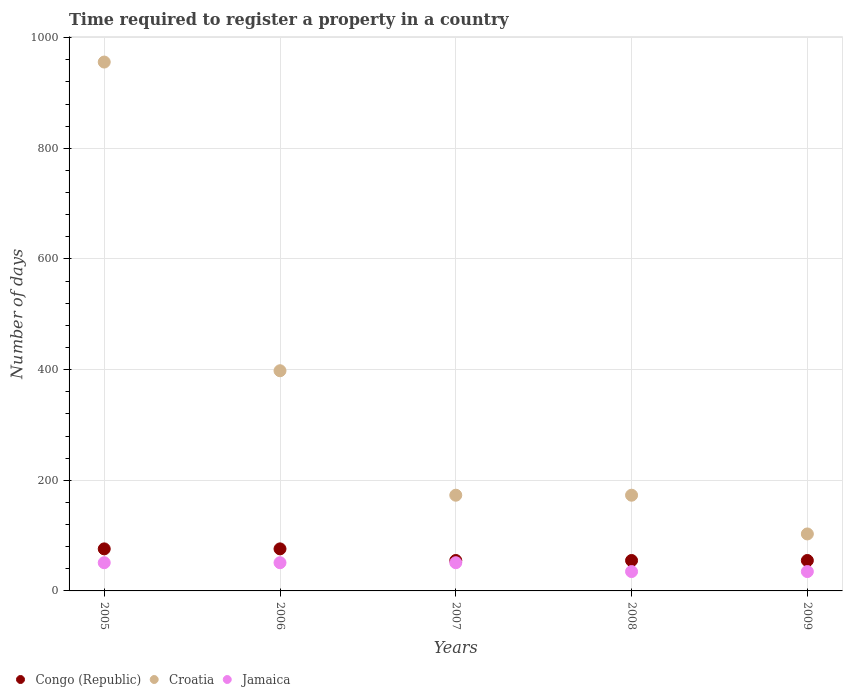Is the number of dotlines equal to the number of legend labels?
Your answer should be very brief. Yes. What is the number of days required to register a property in Congo (Republic) in 2005?
Offer a terse response. 76. Across all years, what is the maximum number of days required to register a property in Croatia?
Your answer should be very brief. 956. Across all years, what is the minimum number of days required to register a property in Congo (Republic)?
Keep it short and to the point. 55. What is the total number of days required to register a property in Jamaica in the graph?
Your response must be concise. 223. What is the difference between the number of days required to register a property in Croatia in 2005 and that in 2007?
Offer a very short reply. 783. What is the difference between the number of days required to register a property in Congo (Republic) in 2005 and the number of days required to register a property in Jamaica in 2007?
Keep it short and to the point. 25. What is the average number of days required to register a property in Croatia per year?
Give a very brief answer. 360.6. In how many years, is the number of days required to register a property in Jamaica greater than 280 days?
Your answer should be compact. 0. What is the ratio of the number of days required to register a property in Jamaica in 2007 to that in 2009?
Your answer should be compact. 1.46. Is the number of days required to register a property in Croatia in 2006 less than that in 2008?
Offer a terse response. No. What is the difference between the highest and the lowest number of days required to register a property in Jamaica?
Ensure brevity in your answer.  16. In how many years, is the number of days required to register a property in Jamaica greater than the average number of days required to register a property in Jamaica taken over all years?
Your answer should be very brief. 3. Is the sum of the number of days required to register a property in Croatia in 2005 and 2009 greater than the maximum number of days required to register a property in Jamaica across all years?
Your answer should be very brief. Yes. Does the number of days required to register a property in Congo (Republic) monotonically increase over the years?
Provide a succinct answer. No. Is the number of days required to register a property in Congo (Republic) strictly less than the number of days required to register a property in Croatia over the years?
Offer a very short reply. Yes. How many dotlines are there?
Keep it short and to the point. 3. Are the values on the major ticks of Y-axis written in scientific E-notation?
Provide a succinct answer. No. Does the graph contain any zero values?
Offer a terse response. No. What is the title of the graph?
Your response must be concise. Time required to register a property in a country. Does "Namibia" appear as one of the legend labels in the graph?
Keep it short and to the point. No. What is the label or title of the X-axis?
Give a very brief answer. Years. What is the label or title of the Y-axis?
Offer a terse response. Number of days. What is the Number of days of Croatia in 2005?
Ensure brevity in your answer.  956. What is the Number of days in Congo (Republic) in 2006?
Keep it short and to the point. 76. What is the Number of days in Croatia in 2006?
Your answer should be compact. 398. What is the Number of days of Congo (Republic) in 2007?
Keep it short and to the point. 55. What is the Number of days of Croatia in 2007?
Your response must be concise. 173. What is the Number of days in Congo (Republic) in 2008?
Make the answer very short. 55. What is the Number of days of Croatia in 2008?
Your answer should be very brief. 173. What is the Number of days in Congo (Republic) in 2009?
Your answer should be compact. 55. What is the Number of days in Croatia in 2009?
Offer a terse response. 103. Across all years, what is the maximum Number of days of Congo (Republic)?
Your answer should be very brief. 76. Across all years, what is the maximum Number of days in Croatia?
Your response must be concise. 956. Across all years, what is the minimum Number of days in Croatia?
Provide a short and direct response. 103. Across all years, what is the minimum Number of days in Jamaica?
Provide a short and direct response. 35. What is the total Number of days in Congo (Republic) in the graph?
Ensure brevity in your answer.  317. What is the total Number of days in Croatia in the graph?
Offer a very short reply. 1803. What is the total Number of days of Jamaica in the graph?
Keep it short and to the point. 223. What is the difference between the Number of days in Croatia in 2005 and that in 2006?
Offer a terse response. 558. What is the difference between the Number of days in Jamaica in 2005 and that in 2006?
Provide a short and direct response. 0. What is the difference between the Number of days in Congo (Republic) in 2005 and that in 2007?
Provide a short and direct response. 21. What is the difference between the Number of days of Croatia in 2005 and that in 2007?
Give a very brief answer. 783. What is the difference between the Number of days of Jamaica in 2005 and that in 2007?
Your response must be concise. 0. What is the difference between the Number of days in Congo (Republic) in 2005 and that in 2008?
Ensure brevity in your answer.  21. What is the difference between the Number of days in Croatia in 2005 and that in 2008?
Offer a terse response. 783. What is the difference between the Number of days of Jamaica in 2005 and that in 2008?
Give a very brief answer. 16. What is the difference between the Number of days in Congo (Republic) in 2005 and that in 2009?
Your answer should be very brief. 21. What is the difference between the Number of days in Croatia in 2005 and that in 2009?
Provide a short and direct response. 853. What is the difference between the Number of days in Jamaica in 2005 and that in 2009?
Provide a succinct answer. 16. What is the difference between the Number of days in Congo (Republic) in 2006 and that in 2007?
Your response must be concise. 21. What is the difference between the Number of days of Croatia in 2006 and that in 2007?
Your response must be concise. 225. What is the difference between the Number of days of Jamaica in 2006 and that in 2007?
Your response must be concise. 0. What is the difference between the Number of days in Croatia in 2006 and that in 2008?
Provide a succinct answer. 225. What is the difference between the Number of days of Jamaica in 2006 and that in 2008?
Offer a terse response. 16. What is the difference between the Number of days in Congo (Republic) in 2006 and that in 2009?
Offer a very short reply. 21. What is the difference between the Number of days in Croatia in 2006 and that in 2009?
Your response must be concise. 295. What is the difference between the Number of days in Jamaica in 2006 and that in 2009?
Offer a terse response. 16. What is the difference between the Number of days of Congo (Republic) in 2007 and that in 2009?
Your response must be concise. 0. What is the difference between the Number of days of Congo (Republic) in 2008 and that in 2009?
Provide a succinct answer. 0. What is the difference between the Number of days of Croatia in 2008 and that in 2009?
Keep it short and to the point. 70. What is the difference between the Number of days of Congo (Republic) in 2005 and the Number of days of Croatia in 2006?
Ensure brevity in your answer.  -322. What is the difference between the Number of days of Croatia in 2005 and the Number of days of Jamaica in 2006?
Make the answer very short. 905. What is the difference between the Number of days in Congo (Republic) in 2005 and the Number of days in Croatia in 2007?
Offer a very short reply. -97. What is the difference between the Number of days in Congo (Republic) in 2005 and the Number of days in Jamaica in 2007?
Provide a succinct answer. 25. What is the difference between the Number of days in Croatia in 2005 and the Number of days in Jamaica in 2007?
Provide a succinct answer. 905. What is the difference between the Number of days in Congo (Republic) in 2005 and the Number of days in Croatia in 2008?
Ensure brevity in your answer.  -97. What is the difference between the Number of days of Croatia in 2005 and the Number of days of Jamaica in 2008?
Give a very brief answer. 921. What is the difference between the Number of days of Congo (Republic) in 2005 and the Number of days of Croatia in 2009?
Keep it short and to the point. -27. What is the difference between the Number of days in Congo (Republic) in 2005 and the Number of days in Jamaica in 2009?
Make the answer very short. 41. What is the difference between the Number of days of Croatia in 2005 and the Number of days of Jamaica in 2009?
Your answer should be very brief. 921. What is the difference between the Number of days of Congo (Republic) in 2006 and the Number of days of Croatia in 2007?
Your answer should be compact. -97. What is the difference between the Number of days in Congo (Republic) in 2006 and the Number of days in Jamaica in 2007?
Make the answer very short. 25. What is the difference between the Number of days of Croatia in 2006 and the Number of days of Jamaica in 2007?
Keep it short and to the point. 347. What is the difference between the Number of days of Congo (Republic) in 2006 and the Number of days of Croatia in 2008?
Offer a very short reply. -97. What is the difference between the Number of days in Croatia in 2006 and the Number of days in Jamaica in 2008?
Offer a terse response. 363. What is the difference between the Number of days in Congo (Republic) in 2006 and the Number of days in Croatia in 2009?
Give a very brief answer. -27. What is the difference between the Number of days in Congo (Republic) in 2006 and the Number of days in Jamaica in 2009?
Ensure brevity in your answer.  41. What is the difference between the Number of days of Croatia in 2006 and the Number of days of Jamaica in 2009?
Provide a succinct answer. 363. What is the difference between the Number of days of Congo (Republic) in 2007 and the Number of days of Croatia in 2008?
Offer a terse response. -118. What is the difference between the Number of days in Congo (Republic) in 2007 and the Number of days in Jamaica in 2008?
Keep it short and to the point. 20. What is the difference between the Number of days in Croatia in 2007 and the Number of days in Jamaica in 2008?
Provide a succinct answer. 138. What is the difference between the Number of days in Congo (Republic) in 2007 and the Number of days in Croatia in 2009?
Offer a terse response. -48. What is the difference between the Number of days of Congo (Republic) in 2007 and the Number of days of Jamaica in 2009?
Your answer should be very brief. 20. What is the difference between the Number of days of Croatia in 2007 and the Number of days of Jamaica in 2009?
Your answer should be compact. 138. What is the difference between the Number of days in Congo (Republic) in 2008 and the Number of days in Croatia in 2009?
Keep it short and to the point. -48. What is the difference between the Number of days of Croatia in 2008 and the Number of days of Jamaica in 2009?
Give a very brief answer. 138. What is the average Number of days of Congo (Republic) per year?
Give a very brief answer. 63.4. What is the average Number of days of Croatia per year?
Give a very brief answer. 360.6. What is the average Number of days of Jamaica per year?
Your answer should be very brief. 44.6. In the year 2005, what is the difference between the Number of days of Congo (Republic) and Number of days of Croatia?
Your answer should be very brief. -880. In the year 2005, what is the difference between the Number of days of Congo (Republic) and Number of days of Jamaica?
Make the answer very short. 25. In the year 2005, what is the difference between the Number of days in Croatia and Number of days in Jamaica?
Your answer should be very brief. 905. In the year 2006, what is the difference between the Number of days in Congo (Republic) and Number of days in Croatia?
Your answer should be compact. -322. In the year 2006, what is the difference between the Number of days in Congo (Republic) and Number of days in Jamaica?
Offer a terse response. 25. In the year 2006, what is the difference between the Number of days in Croatia and Number of days in Jamaica?
Make the answer very short. 347. In the year 2007, what is the difference between the Number of days in Congo (Republic) and Number of days in Croatia?
Provide a succinct answer. -118. In the year 2007, what is the difference between the Number of days of Croatia and Number of days of Jamaica?
Ensure brevity in your answer.  122. In the year 2008, what is the difference between the Number of days in Congo (Republic) and Number of days in Croatia?
Ensure brevity in your answer.  -118. In the year 2008, what is the difference between the Number of days of Congo (Republic) and Number of days of Jamaica?
Your answer should be compact. 20. In the year 2008, what is the difference between the Number of days of Croatia and Number of days of Jamaica?
Provide a short and direct response. 138. In the year 2009, what is the difference between the Number of days in Congo (Republic) and Number of days in Croatia?
Provide a succinct answer. -48. What is the ratio of the Number of days of Congo (Republic) in 2005 to that in 2006?
Make the answer very short. 1. What is the ratio of the Number of days of Croatia in 2005 to that in 2006?
Your answer should be very brief. 2.4. What is the ratio of the Number of days in Congo (Republic) in 2005 to that in 2007?
Provide a succinct answer. 1.38. What is the ratio of the Number of days in Croatia in 2005 to that in 2007?
Offer a terse response. 5.53. What is the ratio of the Number of days of Congo (Republic) in 2005 to that in 2008?
Ensure brevity in your answer.  1.38. What is the ratio of the Number of days in Croatia in 2005 to that in 2008?
Your answer should be very brief. 5.53. What is the ratio of the Number of days in Jamaica in 2005 to that in 2008?
Your response must be concise. 1.46. What is the ratio of the Number of days in Congo (Republic) in 2005 to that in 2009?
Your answer should be compact. 1.38. What is the ratio of the Number of days in Croatia in 2005 to that in 2009?
Offer a terse response. 9.28. What is the ratio of the Number of days in Jamaica in 2005 to that in 2009?
Your response must be concise. 1.46. What is the ratio of the Number of days in Congo (Republic) in 2006 to that in 2007?
Keep it short and to the point. 1.38. What is the ratio of the Number of days of Croatia in 2006 to that in 2007?
Your response must be concise. 2.3. What is the ratio of the Number of days in Jamaica in 2006 to that in 2007?
Offer a terse response. 1. What is the ratio of the Number of days of Congo (Republic) in 2006 to that in 2008?
Offer a terse response. 1.38. What is the ratio of the Number of days in Croatia in 2006 to that in 2008?
Your answer should be very brief. 2.3. What is the ratio of the Number of days of Jamaica in 2006 to that in 2008?
Offer a terse response. 1.46. What is the ratio of the Number of days in Congo (Republic) in 2006 to that in 2009?
Your answer should be very brief. 1.38. What is the ratio of the Number of days in Croatia in 2006 to that in 2009?
Offer a very short reply. 3.86. What is the ratio of the Number of days in Jamaica in 2006 to that in 2009?
Your answer should be compact. 1.46. What is the ratio of the Number of days in Congo (Republic) in 2007 to that in 2008?
Offer a terse response. 1. What is the ratio of the Number of days in Jamaica in 2007 to that in 2008?
Provide a succinct answer. 1.46. What is the ratio of the Number of days of Croatia in 2007 to that in 2009?
Offer a very short reply. 1.68. What is the ratio of the Number of days in Jamaica in 2007 to that in 2009?
Provide a short and direct response. 1.46. What is the ratio of the Number of days of Croatia in 2008 to that in 2009?
Make the answer very short. 1.68. What is the difference between the highest and the second highest Number of days of Congo (Republic)?
Offer a terse response. 0. What is the difference between the highest and the second highest Number of days in Croatia?
Make the answer very short. 558. What is the difference between the highest and the lowest Number of days of Croatia?
Ensure brevity in your answer.  853. 